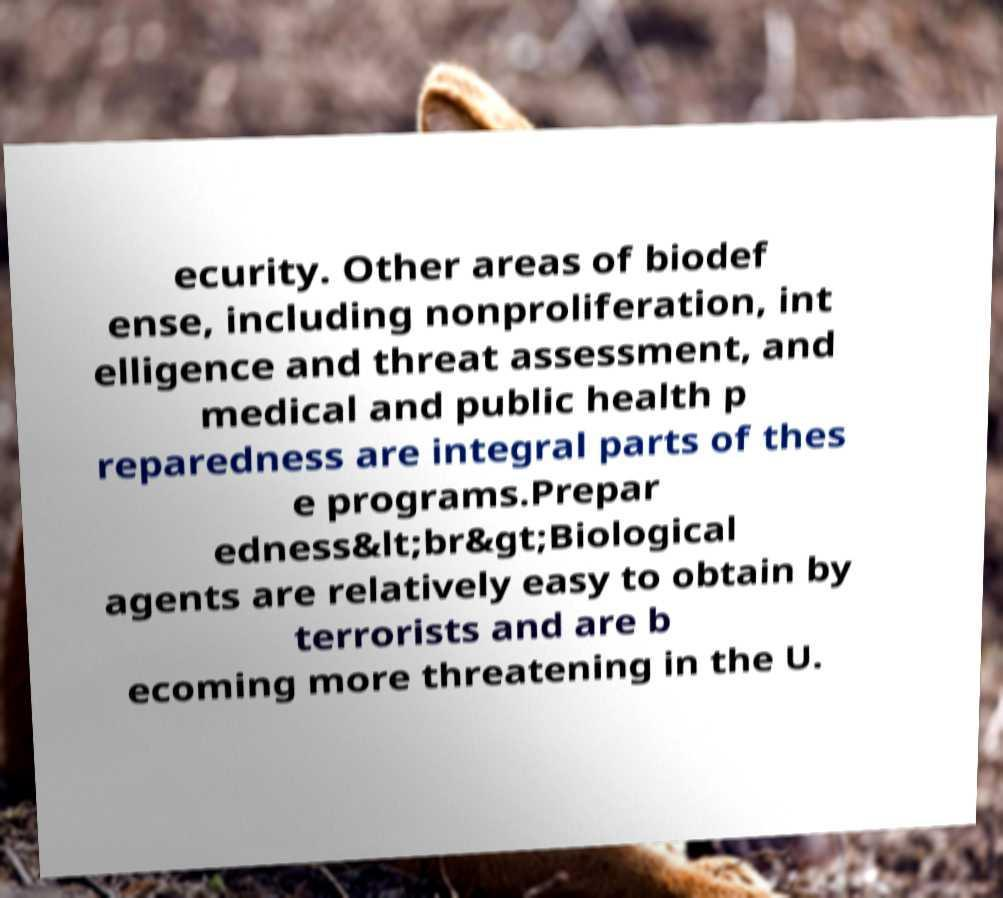For documentation purposes, I need the text within this image transcribed. Could you provide that? ecurity. Other areas of biodef ense, including nonproliferation, int elligence and threat assessment, and medical and public health p reparedness are integral parts of thes e programs.Prepar edness&lt;br&gt;Biological agents are relatively easy to obtain by terrorists and are b ecoming more threatening in the U. 